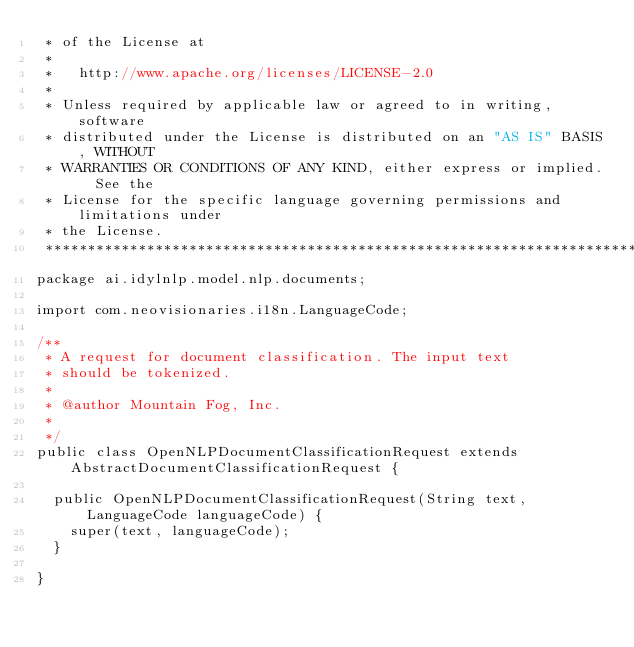Convert code to text. <code><loc_0><loc_0><loc_500><loc_500><_Java_> * of the License at
 *
 *   http://www.apache.org/licenses/LICENSE-2.0
 *
 * Unless required by applicable law or agreed to in writing, software
 * distributed under the License is distributed on an "AS IS" BASIS, WITHOUT
 * WARRANTIES OR CONDITIONS OF ANY KIND, either express or implied.  See the
 * License for the specific language governing permissions and limitations under
 * the License.
 ******************************************************************************/
package ai.idylnlp.model.nlp.documents;

import com.neovisionaries.i18n.LanguageCode;

/**
 * A request for document classification. The input text
 * should be tokenized.
 *
 * @author Mountain Fog, Inc.
 *
 */
public class OpenNLPDocumentClassificationRequest extends AbstractDocumentClassificationRequest {

  public OpenNLPDocumentClassificationRequest(String text, LanguageCode languageCode) {
    super(text, languageCode);
  }

}
</code> 